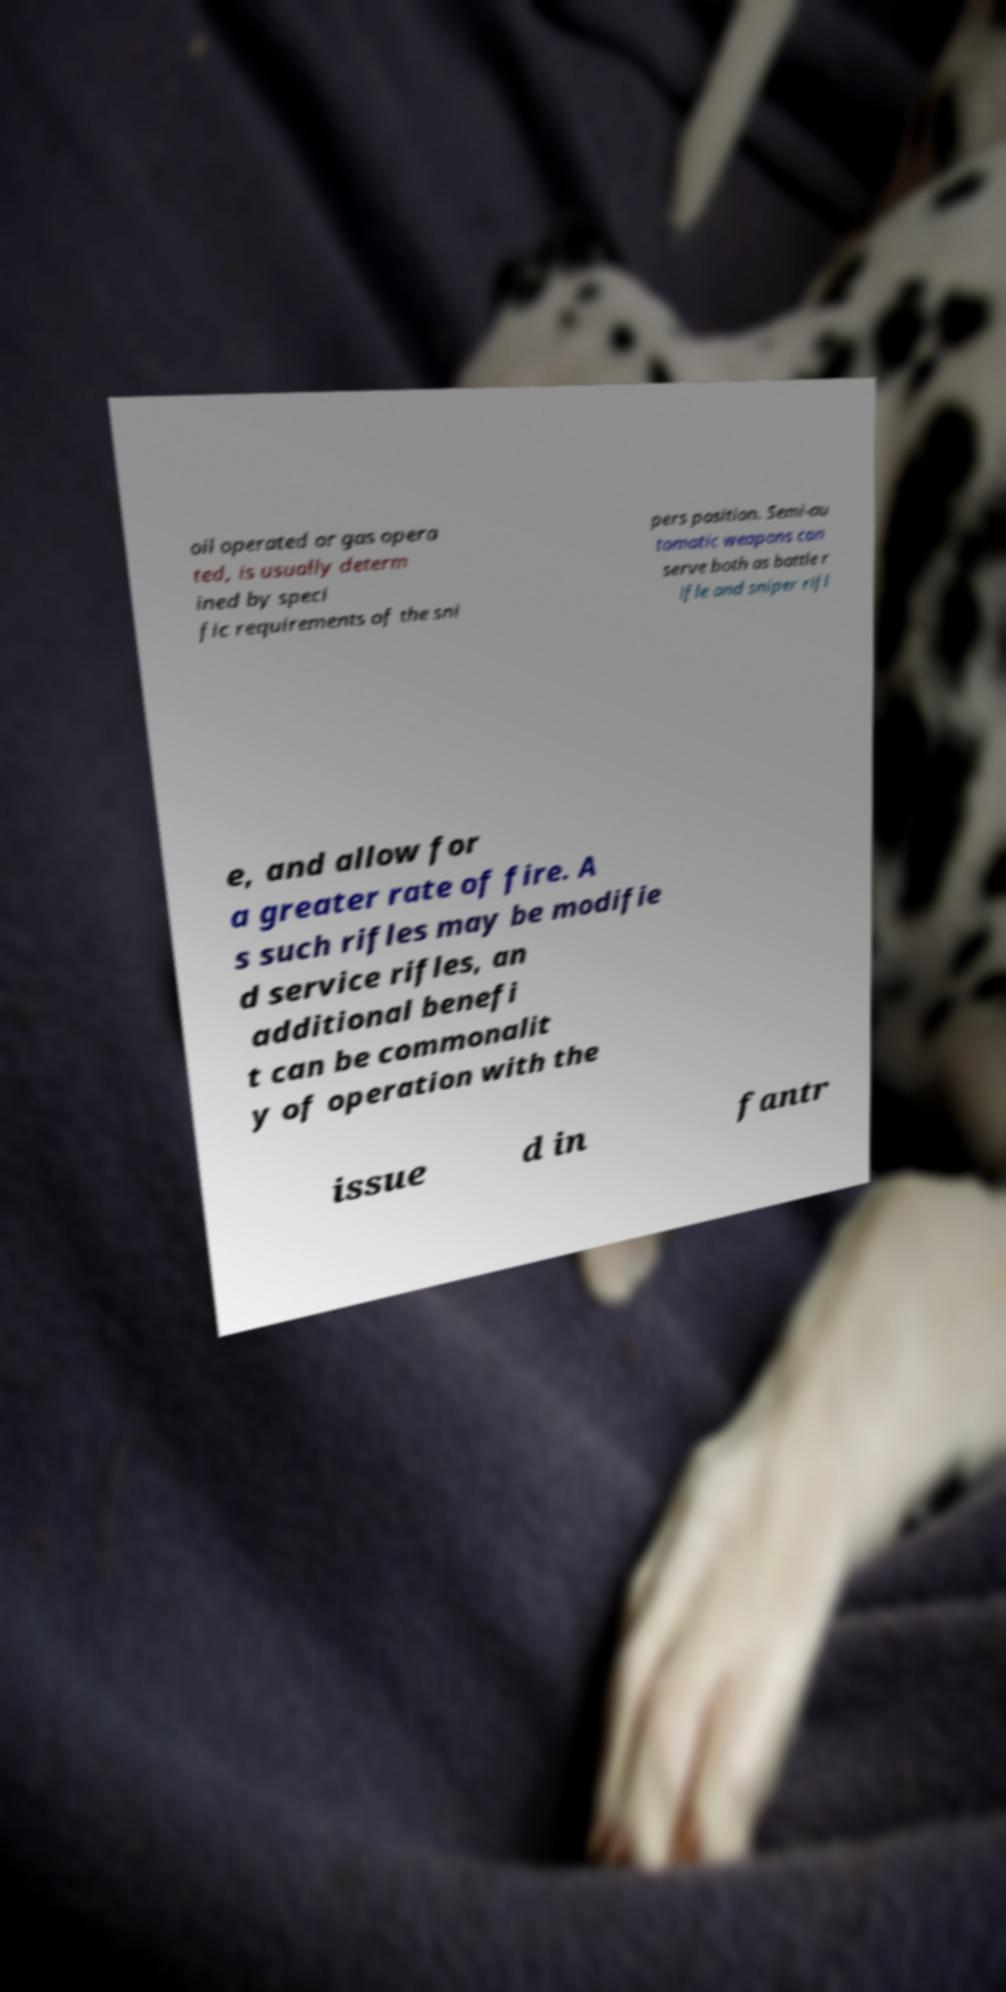Could you extract and type out the text from this image? oil operated or gas opera ted, is usually determ ined by speci fic requirements of the sni pers position. Semi-au tomatic weapons can serve both as battle r ifle and sniper rifl e, and allow for a greater rate of fire. A s such rifles may be modifie d service rifles, an additional benefi t can be commonalit y of operation with the issue d in fantr 